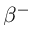Convert formula to latex. <formula><loc_0><loc_0><loc_500><loc_500>\beta ^ { - }</formula> 